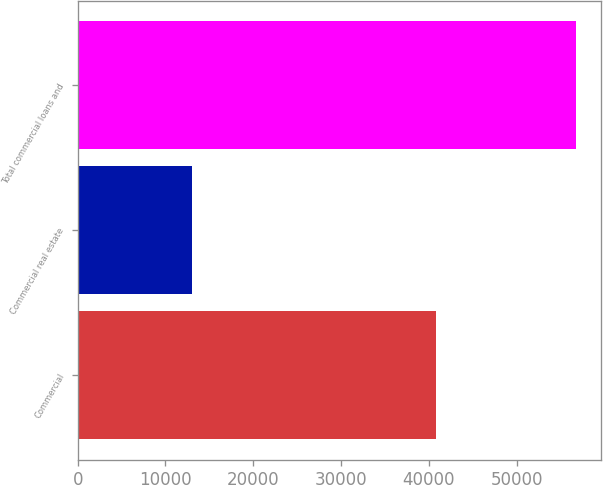<chart> <loc_0><loc_0><loc_500><loc_500><bar_chart><fcel>Commercial<fcel>Commercial real estate<fcel>Total commercial loans and<nl><fcel>40857<fcel>13023<fcel>56783<nl></chart> 